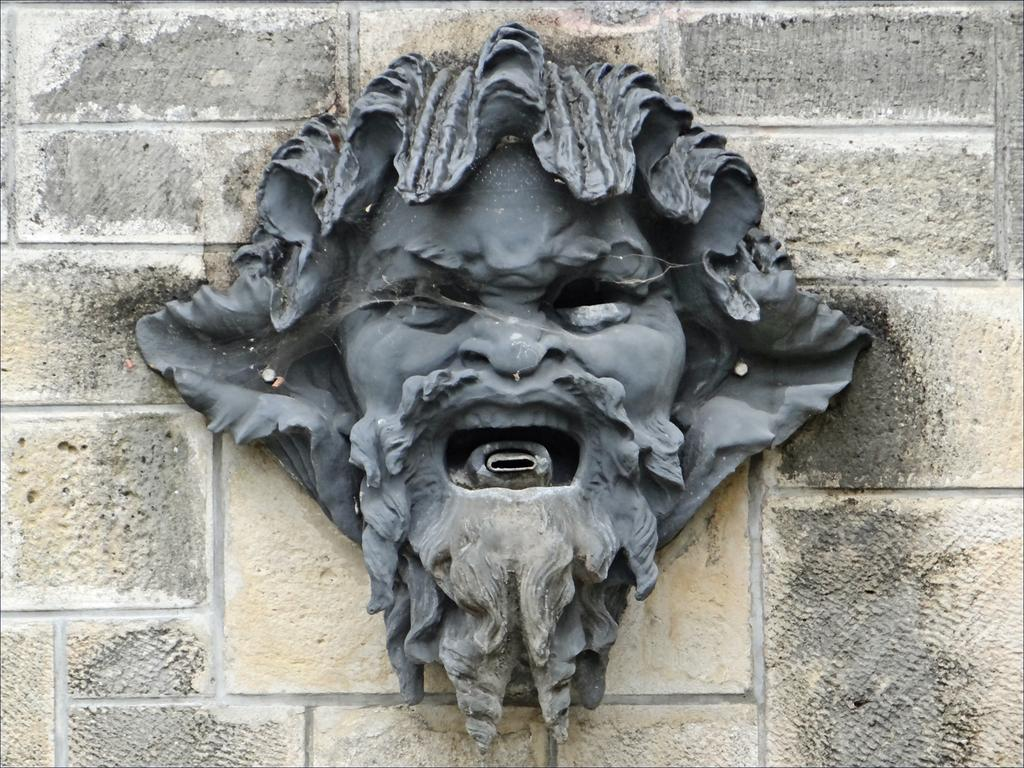What is the main subject of the image? There is a statue in the image. Where is the statue located? The statue is on a wall. What type of coal is being used to support the statue in the image? There is no coal present in the image, and the statue is not supported by any coal. 